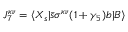Convert formula to latex. <formula><loc_0><loc_0><loc_500><loc_500>J _ { 7 } ^ { \kappa \nu } = \langle X _ { s } | \bar { s } \sigma ^ { \kappa \nu } ( 1 + \gamma _ { 5 } ) b | B \rangle</formula> 